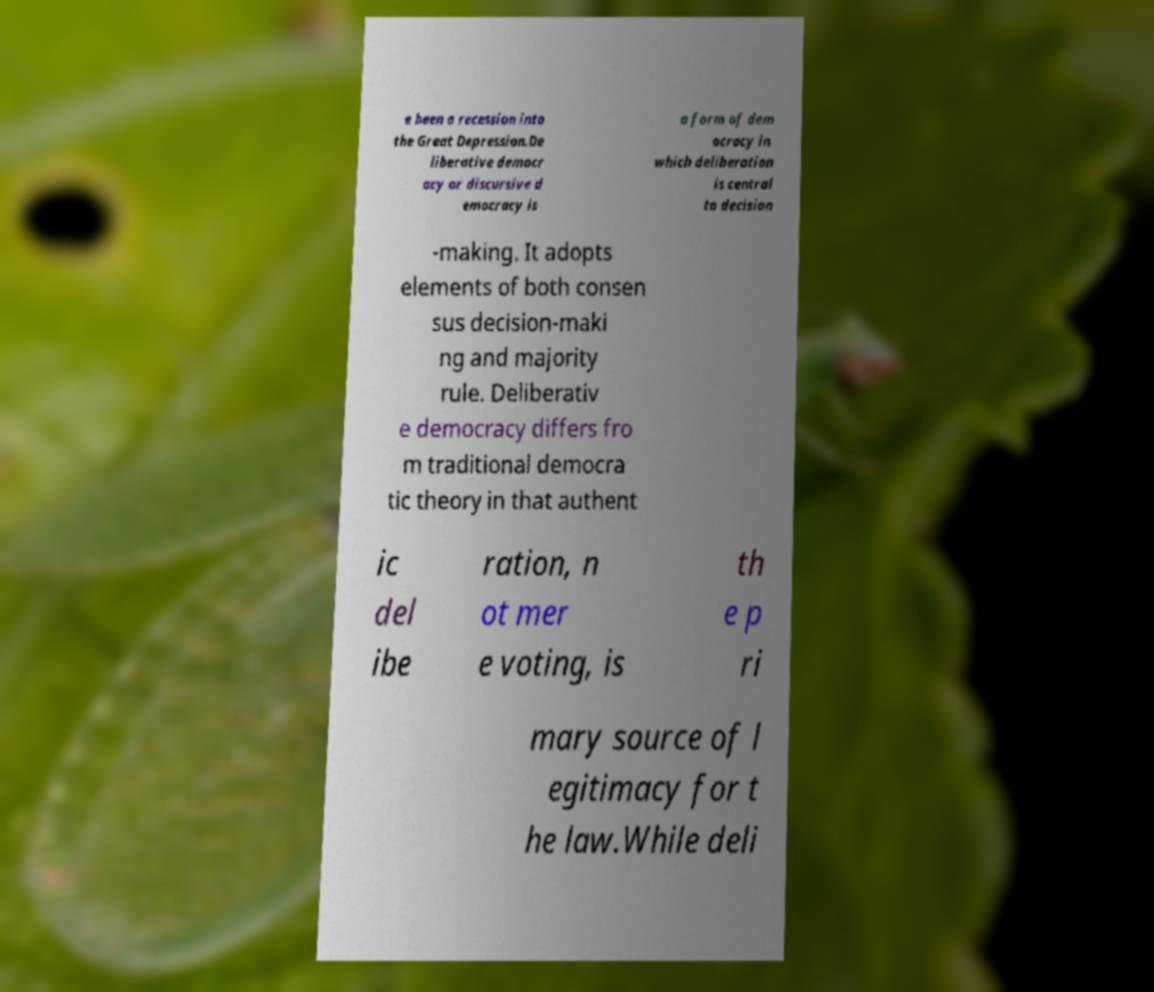There's text embedded in this image that I need extracted. Can you transcribe it verbatim? e been a recession into the Great Depression.De liberative democr acy or discursive d emocracy is a form of dem ocracy in which deliberation is central to decision -making. It adopts elements of both consen sus decision-maki ng and majority rule. Deliberativ e democracy differs fro m traditional democra tic theory in that authent ic del ibe ration, n ot mer e voting, is th e p ri mary source of l egitimacy for t he law.While deli 